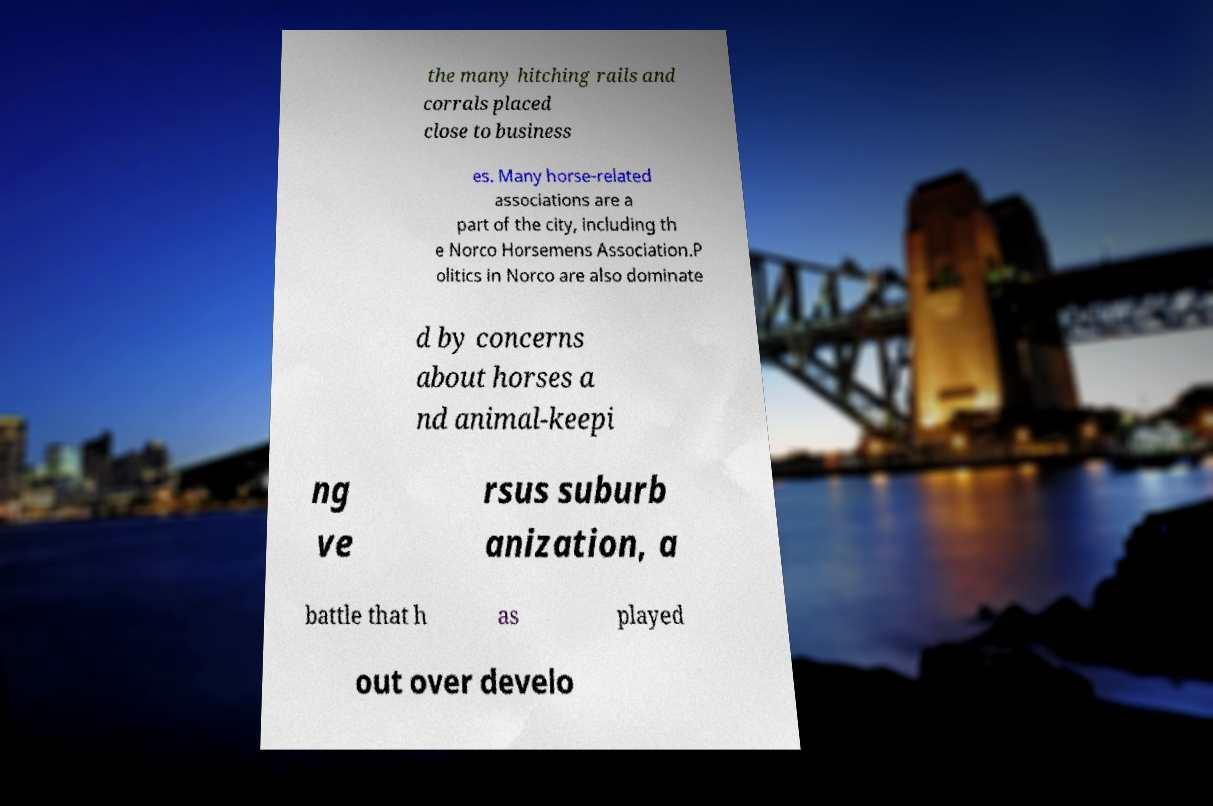Please identify and transcribe the text found in this image. the many hitching rails and corrals placed close to business es. Many horse-related associations are a part of the city, including th e Norco Horsemens Association.P olitics in Norco are also dominate d by concerns about horses a nd animal-keepi ng ve rsus suburb anization, a battle that h as played out over develo 